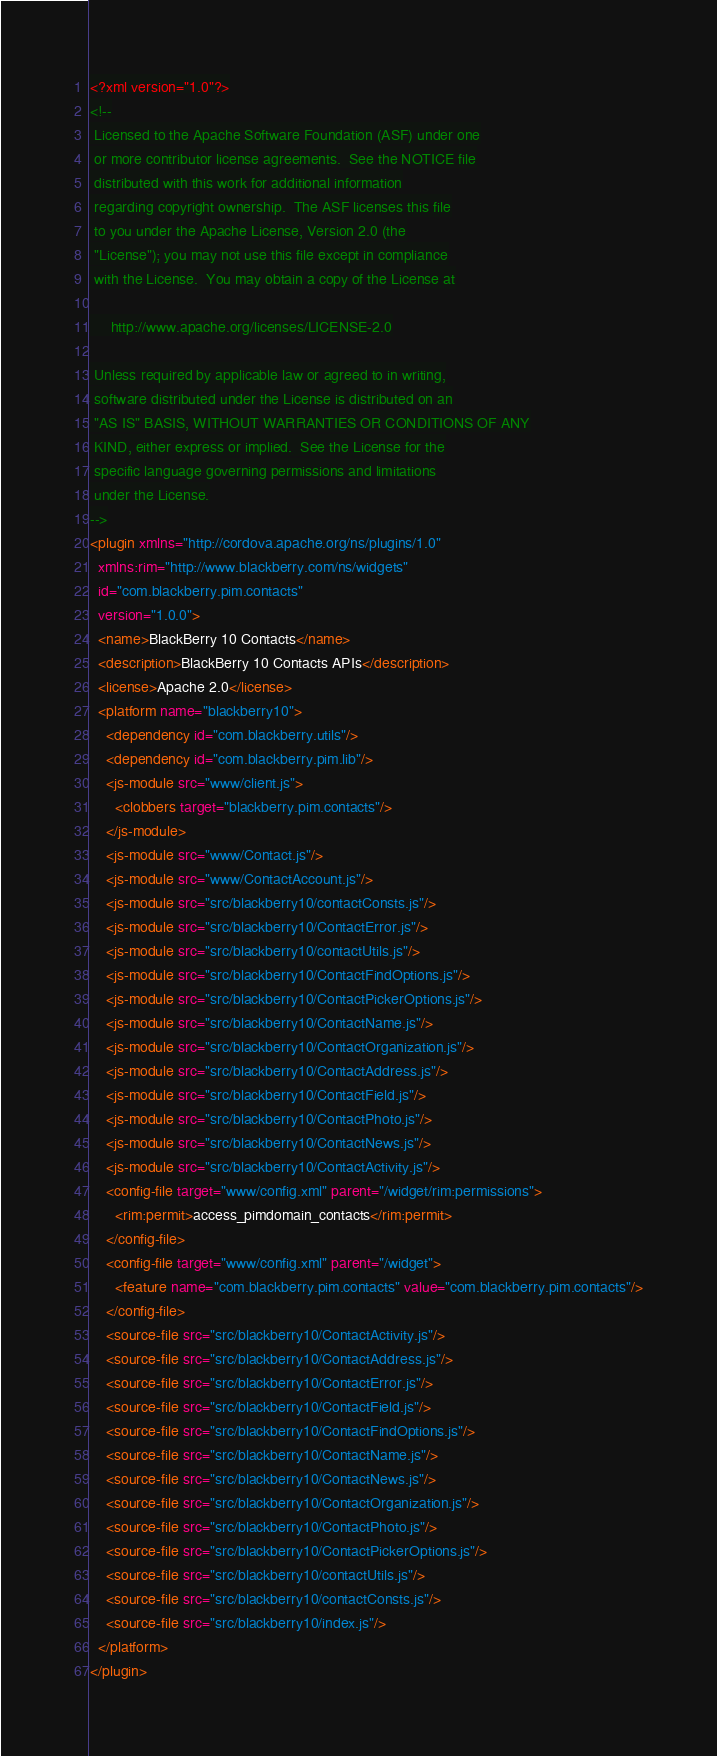<code> <loc_0><loc_0><loc_500><loc_500><_XML_><?xml version="1.0"?>
<!--
 Licensed to the Apache Software Foundation (ASF) under one
 or more contributor license agreements.  See the NOTICE file
 distributed with this work for additional information
 regarding copyright ownership.  The ASF licenses this file
 to you under the Apache License, Version 2.0 (the
 "License"); you may not use this file except in compliance
 with the License.  You may obtain a copy of the License at

     http://www.apache.org/licenses/LICENSE-2.0

 Unless required by applicable law or agreed to in writing,
 software distributed under the License is distributed on an
 "AS IS" BASIS, WITHOUT WARRANTIES OR CONDITIONS OF ANY
 KIND, either express or implied.  See the License for the
 specific language governing permissions and limitations
 under the License.
-->
<plugin xmlns="http://cordova.apache.org/ns/plugins/1.0"
  xmlns:rim="http://www.blackberry.com/ns/widgets"
  id="com.blackberry.pim.contacts"
  version="1.0.0">
  <name>BlackBerry 10 Contacts</name>
  <description>BlackBerry 10 Contacts APIs</description>
  <license>Apache 2.0</license>
  <platform name="blackberry10">
    <dependency id="com.blackberry.utils"/>
    <dependency id="com.blackberry.pim.lib"/>
    <js-module src="www/client.js">
      <clobbers target="blackberry.pim.contacts"/>
    </js-module>
    <js-module src="www/Contact.js"/>
    <js-module src="www/ContactAccount.js"/>
    <js-module src="src/blackberry10/contactConsts.js"/>
    <js-module src="src/blackberry10/ContactError.js"/>
    <js-module src="src/blackberry10/contactUtils.js"/>
    <js-module src="src/blackberry10/ContactFindOptions.js"/>
    <js-module src="src/blackberry10/ContactPickerOptions.js"/>
    <js-module src="src/blackberry10/ContactName.js"/>
    <js-module src="src/blackberry10/ContactOrganization.js"/>
    <js-module src="src/blackberry10/ContactAddress.js"/>
    <js-module src="src/blackberry10/ContactField.js"/>
    <js-module src="src/blackberry10/ContactPhoto.js"/>
    <js-module src="src/blackberry10/ContactNews.js"/>
    <js-module src="src/blackberry10/ContactActivity.js"/>
    <config-file target="www/config.xml" parent="/widget/rim:permissions">
      <rim:permit>access_pimdomain_contacts</rim:permit>
    </config-file>
    <config-file target="www/config.xml" parent="/widget">
      <feature name="com.blackberry.pim.contacts" value="com.blackberry.pim.contacts"/>
    </config-file>
    <source-file src="src/blackberry10/ContactActivity.js"/>
    <source-file src="src/blackberry10/ContactAddress.js"/>
    <source-file src="src/blackberry10/ContactError.js"/>
    <source-file src="src/blackberry10/ContactField.js"/>
    <source-file src="src/blackberry10/ContactFindOptions.js"/>
    <source-file src="src/blackberry10/ContactName.js"/>
    <source-file src="src/blackberry10/ContactNews.js"/>
    <source-file src="src/blackberry10/ContactOrganization.js"/>
    <source-file src="src/blackberry10/ContactPhoto.js"/>
    <source-file src="src/blackberry10/ContactPickerOptions.js"/>
    <source-file src="src/blackberry10/contactUtils.js"/>
    <source-file src="src/blackberry10/contactConsts.js"/>
    <source-file src="src/blackberry10/index.js"/>
  </platform>
</plugin>
</code> 